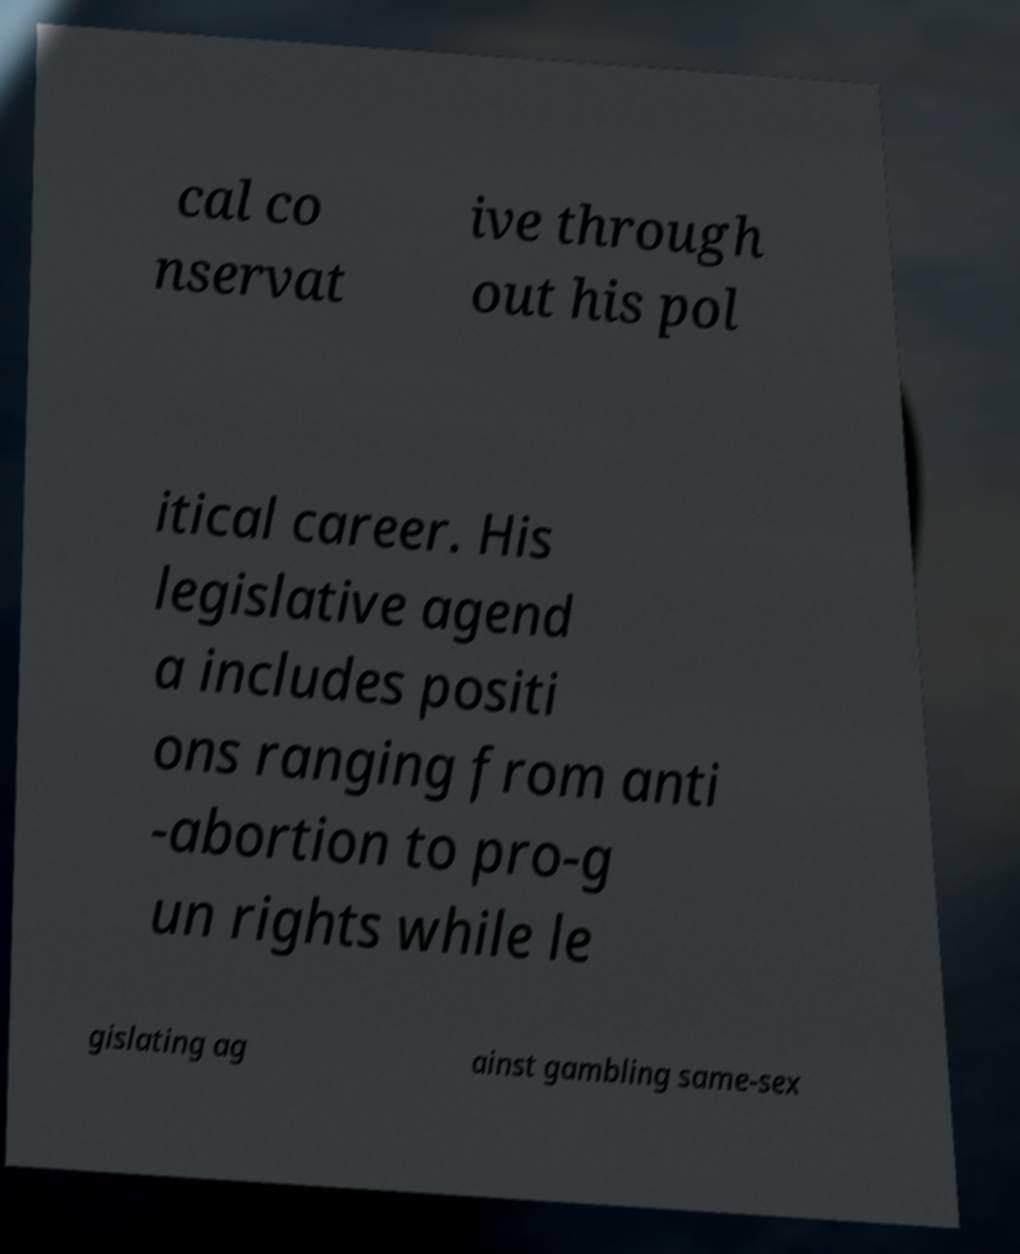Please identify and transcribe the text found in this image. cal co nservat ive through out his pol itical career. His legislative agend a includes positi ons ranging from anti -abortion to pro-g un rights while le gislating ag ainst gambling same-sex 